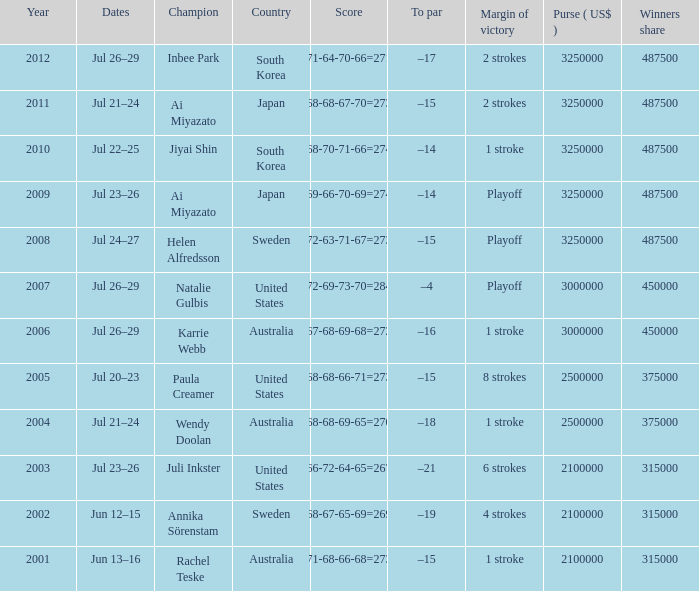How many years was Jiyai Shin the champion? 1.0. Parse the table in full. {'header': ['Year', 'Dates', 'Champion', 'Country', 'Score', 'To par', 'Margin of victory', 'Purse ( US$ )', 'Winners share'], 'rows': [['2012', 'Jul 26–29', 'Inbee Park', 'South Korea', '71-64-70-66=271', '–17', '2 strokes', '3250000', '487500'], ['2011', 'Jul 21–24', 'Ai Miyazato', 'Japan', '68-68-67-70=273', '–15', '2 strokes', '3250000', '487500'], ['2010', 'Jul 22–25', 'Jiyai Shin', 'South Korea', '68-70-71-66=274', '–14', '1 stroke', '3250000', '487500'], ['2009', 'Jul 23–26', 'Ai Miyazato', 'Japan', '69-66-70-69=274', '–14', 'Playoff', '3250000', '487500'], ['2008', 'Jul 24–27', 'Helen Alfredsson', 'Sweden', '72-63-71-67=273', '–15', 'Playoff', '3250000', '487500'], ['2007', 'Jul 26–29', 'Natalie Gulbis', 'United States', '72-69-73-70=284', '–4', 'Playoff', '3000000', '450000'], ['2006', 'Jul 26–29', 'Karrie Webb', 'Australia', '67-68-69-68=272', '–16', '1 stroke', '3000000', '450000'], ['2005', 'Jul 20–23', 'Paula Creamer', 'United States', '68-68-66-71=273', '–15', '8 strokes', '2500000', '375000'], ['2004', 'Jul 21–24', 'Wendy Doolan', 'Australia', '68-68-69-65=270', '–18', '1 stroke', '2500000', '375000'], ['2003', 'Jul 23–26', 'Juli Inkster', 'United States', '66-72-64-65=267', '–21', '6 strokes', '2100000', '315000'], ['2002', 'Jun 12–15', 'Annika Sörenstam', 'Sweden', '68-67-65-69=269', '–19', '4 strokes', '2100000', '315000'], ['2001', 'Jun 13–16', 'Rachel Teske', 'Australia', '71-68-66-68=273', '–15', '1 stroke', '2100000', '315000']]} 